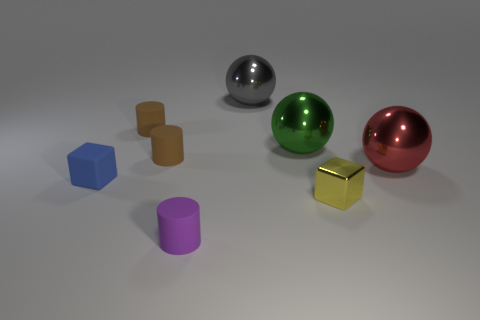Do the gray thing and the red thing that is in front of the large green sphere have the same shape?
Provide a short and direct response. Yes. The object that is in front of the gray shiny object and behind the large green metal object is made of what material?
Give a very brief answer. Rubber. There is a metal cube that is the same size as the blue matte cube; what is its color?
Your response must be concise. Yellow. Does the small blue block have the same material as the cylinder that is in front of the big red ball?
Your response must be concise. Yes. What number of other things are there of the same size as the blue rubber object?
Ensure brevity in your answer.  4. There is a block in front of the cube left of the purple matte cylinder; are there any big red things to the left of it?
Offer a terse response. No. How big is the yellow shiny object?
Provide a succinct answer. Small. What size is the cube that is to the right of the tiny blue matte cube?
Your response must be concise. Small. Is the size of the matte thing that is in front of the blue matte object the same as the red thing?
Ensure brevity in your answer.  No. Are there any other things that have the same color as the tiny metal cube?
Keep it short and to the point. No. 